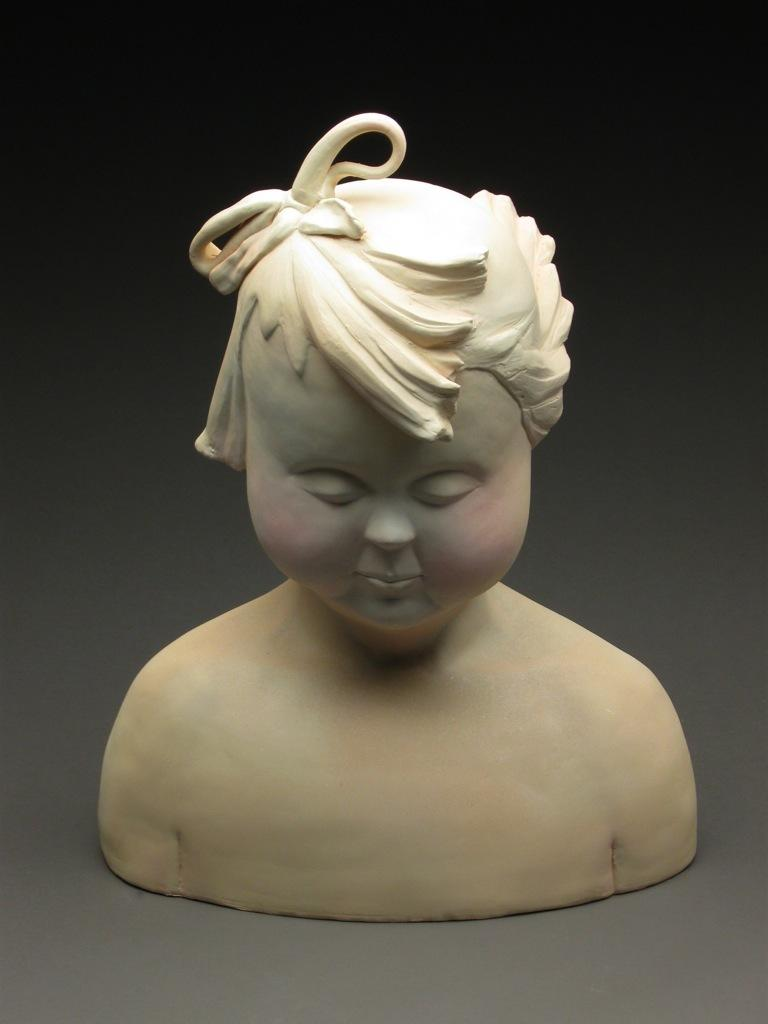What is the main subject in the middle of the image? There is a mannequin in the middle of the image. What type of fire is being used to power the list in the image? There is no fire or list present in the image; it only features a mannequin. 